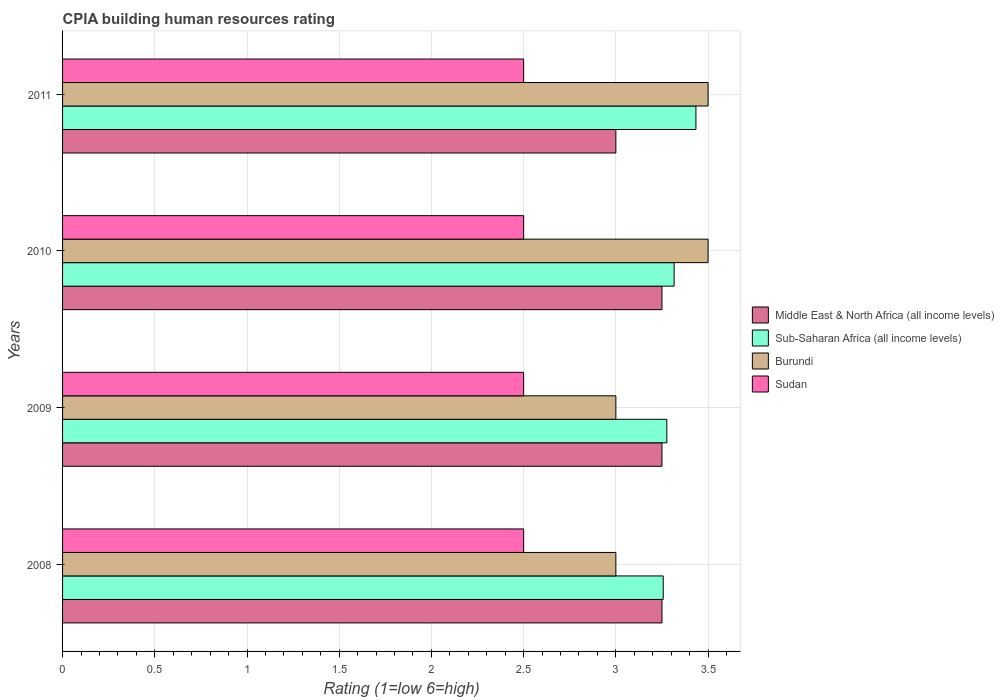Are the number of bars per tick equal to the number of legend labels?
Your response must be concise. Yes. In how many cases, is the number of bars for a given year not equal to the number of legend labels?
Your answer should be very brief. 0. Across all years, what is the minimum CPIA rating in Sudan?
Offer a terse response. 2.5. In which year was the CPIA rating in Middle East & North Africa (all income levels) minimum?
Keep it short and to the point. 2011. What is the total CPIA rating in Middle East & North Africa (all income levels) in the graph?
Keep it short and to the point. 12.75. What is the average CPIA rating in Sub-Saharan Africa (all income levels) per year?
Ensure brevity in your answer.  3.32. In how many years, is the CPIA rating in Burundi greater than 0.30000000000000004 ?
Provide a succinct answer. 4. Is the CPIA rating in Sub-Saharan Africa (all income levels) in 2009 less than that in 2011?
Offer a very short reply. Yes. What is the difference between the highest and the second highest CPIA rating in Sub-Saharan Africa (all income levels)?
Your answer should be compact. 0.12. Is the sum of the CPIA rating in Sudan in 2010 and 2011 greater than the maximum CPIA rating in Burundi across all years?
Offer a very short reply. Yes. Is it the case that in every year, the sum of the CPIA rating in Burundi and CPIA rating in Middle East & North Africa (all income levels) is greater than the sum of CPIA rating in Sudan and CPIA rating in Sub-Saharan Africa (all income levels)?
Offer a terse response. No. What does the 1st bar from the top in 2009 represents?
Offer a very short reply. Sudan. What does the 1st bar from the bottom in 2008 represents?
Your answer should be compact. Middle East & North Africa (all income levels). Is it the case that in every year, the sum of the CPIA rating in Middle East & North Africa (all income levels) and CPIA rating in Sudan is greater than the CPIA rating in Sub-Saharan Africa (all income levels)?
Provide a short and direct response. Yes. How many bars are there?
Provide a short and direct response. 16. How many years are there in the graph?
Give a very brief answer. 4. What is the difference between two consecutive major ticks on the X-axis?
Make the answer very short. 0.5. How many legend labels are there?
Your answer should be compact. 4. What is the title of the graph?
Offer a terse response. CPIA building human resources rating. What is the label or title of the X-axis?
Your response must be concise. Rating (1=low 6=high). What is the label or title of the Y-axis?
Offer a terse response. Years. What is the Rating (1=low 6=high) of Sub-Saharan Africa (all income levels) in 2008?
Your response must be concise. 3.26. What is the Rating (1=low 6=high) in Burundi in 2008?
Give a very brief answer. 3. What is the Rating (1=low 6=high) in Sub-Saharan Africa (all income levels) in 2009?
Your answer should be very brief. 3.28. What is the Rating (1=low 6=high) of Burundi in 2009?
Ensure brevity in your answer.  3. What is the Rating (1=low 6=high) in Sudan in 2009?
Offer a very short reply. 2.5. What is the Rating (1=low 6=high) in Middle East & North Africa (all income levels) in 2010?
Provide a succinct answer. 3.25. What is the Rating (1=low 6=high) in Sub-Saharan Africa (all income levels) in 2010?
Offer a terse response. 3.32. What is the Rating (1=low 6=high) of Middle East & North Africa (all income levels) in 2011?
Your response must be concise. 3. What is the Rating (1=low 6=high) of Sub-Saharan Africa (all income levels) in 2011?
Offer a terse response. 3.43. What is the Rating (1=low 6=high) of Burundi in 2011?
Make the answer very short. 3.5. Across all years, what is the maximum Rating (1=low 6=high) in Middle East & North Africa (all income levels)?
Make the answer very short. 3.25. Across all years, what is the maximum Rating (1=low 6=high) in Sub-Saharan Africa (all income levels)?
Offer a terse response. 3.43. Across all years, what is the maximum Rating (1=low 6=high) of Burundi?
Keep it short and to the point. 3.5. Across all years, what is the maximum Rating (1=low 6=high) in Sudan?
Give a very brief answer. 2.5. Across all years, what is the minimum Rating (1=low 6=high) in Middle East & North Africa (all income levels)?
Your answer should be very brief. 3. Across all years, what is the minimum Rating (1=low 6=high) of Sub-Saharan Africa (all income levels)?
Your answer should be compact. 3.26. Across all years, what is the minimum Rating (1=low 6=high) of Sudan?
Offer a terse response. 2.5. What is the total Rating (1=low 6=high) in Middle East & North Africa (all income levels) in the graph?
Keep it short and to the point. 12.75. What is the total Rating (1=low 6=high) of Sub-Saharan Africa (all income levels) in the graph?
Your answer should be very brief. 13.28. What is the total Rating (1=low 6=high) in Burundi in the graph?
Make the answer very short. 13. What is the total Rating (1=low 6=high) in Sudan in the graph?
Your answer should be very brief. 10. What is the difference between the Rating (1=low 6=high) of Middle East & North Africa (all income levels) in 2008 and that in 2009?
Offer a terse response. 0. What is the difference between the Rating (1=low 6=high) of Sub-Saharan Africa (all income levels) in 2008 and that in 2009?
Provide a short and direct response. -0.02. What is the difference between the Rating (1=low 6=high) of Burundi in 2008 and that in 2009?
Make the answer very short. 0. What is the difference between the Rating (1=low 6=high) of Middle East & North Africa (all income levels) in 2008 and that in 2010?
Offer a very short reply. 0. What is the difference between the Rating (1=low 6=high) of Sub-Saharan Africa (all income levels) in 2008 and that in 2010?
Offer a terse response. -0.06. What is the difference between the Rating (1=low 6=high) in Middle East & North Africa (all income levels) in 2008 and that in 2011?
Provide a succinct answer. 0.25. What is the difference between the Rating (1=low 6=high) of Sub-Saharan Africa (all income levels) in 2008 and that in 2011?
Your answer should be very brief. -0.18. What is the difference between the Rating (1=low 6=high) in Burundi in 2008 and that in 2011?
Ensure brevity in your answer.  -0.5. What is the difference between the Rating (1=low 6=high) in Sudan in 2008 and that in 2011?
Keep it short and to the point. 0. What is the difference between the Rating (1=low 6=high) in Sub-Saharan Africa (all income levels) in 2009 and that in 2010?
Offer a terse response. -0.04. What is the difference between the Rating (1=low 6=high) of Burundi in 2009 and that in 2010?
Your answer should be compact. -0.5. What is the difference between the Rating (1=low 6=high) in Sudan in 2009 and that in 2010?
Make the answer very short. 0. What is the difference between the Rating (1=low 6=high) in Middle East & North Africa (all income levels) in 2009 and that in 2011?
Ensure brevity in your answer.  0.25. What is the difference between the Rating (1=low 6=high) of Sub-Saharan Africa (all income levels) in 2009 and that in 2011?
Provide a succinct answer. -0.16. What is the difference between the Rating (1=low 6=high) of Sub-Saharan Africa (all income levels) in 2010 and that in 2011?
Ensure brevity in your answer.  -0.12. What is the difference between the Rating (1=low 6=high) of Burundi in 2010 and that in 2011?
Keep it short and to the point. 0. What is the difference between the Rating (1=low 6=high) of Middle East & North Africa (all income levels) in 2008 and the Rating (1=low 6=high) of Sub-Saharan Africa (all income levels) in 2009?
Ensure brevity in your answer.  -0.03. What is the difference between the Rating (1=low 6=high) of Sub-Saharan Africa (all income levels) in 2008 and the Rating (1=low 6=high) of Burundi in 2009?
Make the answer very short. 0.26. What is the difference between the Rating (1=low 6=high) in Sub-Saharan Africa (all income levels) in 2008 and the Rating (1=low 6=high) in Sudan in 2009?
Your answer should be very brief. 0.76. What is the difference between the Rating (1=low 6=high) in Middle East & North Africa (all income levels) in 2008 and the Rating (1=low 6=high) in Sub-Saharan Africa (all income levels) in 2010?
Ensure brevity in your answer.  -0.07. What is the difference between the Rating (1=low 6=high) in Sub-Saharan Africa (all income levels) in 2008 and the Rating (1=low 6=high) in Burundi in 2010?
Offer a very short reply. -0.24. What is the difference between the Rating (1=low 6=high) of Sub-Saharan Africa (all income levels) in 2008 and the Rating (1=low 6=high) of Sudan in 2010?
Make the answer very short. 0.76. What is the difference between the Rating (1=low 6=high) of Burundi in 2008 and the Rating (1=low 6=high) of Sudan in 2010?
Ensure brevity in your answer.  0.5. What is the difference between the Rating (1=low 6=high) of Middle East & North Africa (all income levels) in 2008 and the Rating (1=low 6=high) of Sub-Saharan Africa (all income levels) in 2011?
Offer a very short reply. -0.18. What is the difference between the Rating (1=low 6=high) of Middle East & North Africa (all income levels) in 2008 and the Rating (1=low 6=high) of Burundi in 2011?
Keep it short and to the point. -0.25. What is the difference between the Rating (1=low 6=high) in Middle East & North Africa (all income levels) in 2008 and the Rating (1=low 6=high) in Sudan in 2011?
Offer a very short reply. 0.75. What is the difference between the Rating (1=low 6=high) of Sub-Saharan Africa (all income levels) in 2008 and the Rating (1=low 6=high) of Burundi in 2011?
Your response must be concise. -0.24. What is the difference between the Rating (1=low 6=high) in Sub-Saharan Africa (all income levels) in 2008 and the Rating (1=low 6=high) in Sudan in 2011?
Provide a succinct answer. 0.76. What is the difference between the Rating (1=low 6=high) in Middle East & North Africa (all income levels) in 2009 and the Rating (1=low 6=high) in Sub-Saharan Africa (all income levels) in 2010?
Provide a short and direct response. -0.07. What is the difference between the Rating (1=low 6=high) in Middle East & North Africa (all income levels) in 2009 and the Rating (1=low 6=high) in Burundi in 2010?
Provide a succinct answer. -0.25. What is the difference between the Rating (1=low 6=high) of Sub-Saharan Africa (all income levels) in 2009 and the Rating (1=low 6=high) of Burundi in 2010?
Keep it short and to the point. -0.22. What is the difference between the Rating (1=low 6=high) of Sub-Saharan Africa (all income levels) in 2009 and the Rating (1=low 6=high) of Sudan in 2010?
Provide a short and direct response. 0.78. What is the difference between the Rating (1=low 6=high) in Burundi in 2009 and the Rating (1=low 6=high) in Sudan in 2010?
Offer a terse response. 0.5. What is the difference between the Rating (1=low 6=high) in Middle East & North Africa (all income levels) in 2009 and the Rating (1=low 6=high) in Sub-Saharan Africa (all income levels) in 2011?
Provide a succinct answer. -0.18. What is the difference between the Rating (1=low 6=high) of Middle East & North Africa (all income levels) in 2009 and the Rating (1=low 6=high) of Burundi in 2011?
Provide a short and direct response. -0.25. What is the difference between the Rating (1=low 6=high) of Middle East & North Africa (all income levels) in 2009 and the Rating (1=low 6=high) of Sudan in 2011?
Provide a short and direct response. 0.75. What is the difference between the Rating (1=low 6=high) in Sub-Saharan Africa (all income levels) in 2009 and the Rating (1=low 6=high) in Burundi in 2011?
Provide a succinct answer. -0.22. What is the difference between the Rating (1=low 6=high) in Sub-Saharan Africa (all income levels) in 2009 and the Rating (1=low 6=high) in Sudan in 2011?
Your answer should be very brief. 0.78. What is the difference between the Rating (1=low 6=high) in Burundi in 2009 and the Rating (1=low 6=high) in Sudan in 2011?
Make the answer very short. 0.5. What is the difference between the Rating (1=low 6=high) in Middle East & North Africa (all income levels) in 2010 and the Rating (1=low 6=high) in Sub-Saharan Africa (all income levels) in 2011?
Your answer should be compact. -0.18. What is the difference between the Rating (1=low 6=high) in Sub-Saharan Africa (all income levels) in 2010 and the Rating (1=low 6=high) in Burundi in 2011?
Your answer should be very brief. -0.18. What is the difference between the Rating (1=low 6=high) of Sub-Saharan Africa (all income levels) in 2010 and the Rating (1=low 6=high) of Sudan in 2011?
Offer a very short reply. 0.82. What is the average Rating (1=low 6=high) of Middle East & North Africa (all income levels) per year?
Your answer should be very brief. 3.19. What is the average Rating (1=low 6=high) of Sub-Saharan Africa (all income levels) per year?
Give a very brief answer. 3.32. What is the average Rating (1=low 6=high) of Sudan per year?
Your answer should be compact. 2.5. In the year 2008, what is the difference between the Rating (1=low 6=high) in Middle East & North Africa (all income levels) and Rating (1=low 6=high) in Sub-Saharan Africa (all income levels)?
Your answer should be very brief. -0.01. In the year 2008, what is the difference between the Rating (1=low 6=high) of Middle East & North Africa (all income levels) and Rating (1=low 6=high) of Burundi?
Your answer should be compact. 0.25. In the year 2008, what is the difference between the Rating (1=low 6=high) of Middle East & North Africa (all income levels) and Rating (1=low 6=high) of Sudan?
Offer a very short reply. 0.75. In the year 2008, what is the difference between the Rating (1=low 6=high) of Sub-Saharan Africa (all income levels) and Rating (1=low 6=high) of Burundi?
Your answer should be very brief. 0.26. In the year 2008, what is the difference between the Rating (1=low 6=high) in Sub-Saharan Africa (all income levels) and Rating (1=low 6=high) in Sudan?
Your response must be concise. 0.76. In the year 2008, what is the difference between the Rating (1=low 6=high) of Burundi and Rating (1=low 6=high) of Sudan?
Your answer should be compact. 0.5. In the year 2009, what is the difference between the Rating (1=low 6=high) in Middle East & North Africa (all income levels) and Rating (1=low 6=high) in Sub-Saharan Africa (all income levels)?
Ensure brevity in your answer.  -0.03. In the year 2009, what is the difference between the Rating (1=low 6=high) of Middle East & North Africa (all income levels) and Rating (1=low 6=high) of Burundi?
Offer a very short reply. 0.25. In the year 2009, what is the difference between the Rating (1=low 6=high) in Middle East & North Africa (all income levels) and Rating (1=low 6=high) in Sudan?
Ensure brevity in your answer.  0.75. In the year 2009, what is the difference between the Rating (1=low 6=high) of Sub-Saharan Africa (all income levels) and Rating (1=low 6=high) of Burundi?
Your answer should be very brief. 0.28. In the year 2009, what is the difference between the Rating (1=low 6=high) of Sub-Saharan Africa (all income levels) and Rating (1=low 6=high) of Sudan?
Your response must be concise. 0.78. In the year 2009, what is the difference between the Rating (1=low 6=high) of Burundi and Rating (1=low 6=high) of Sudan?
Your answer should be very brief. 0.5. In the year 2010, what is the difference between the Rating (1=low 6=high) of Middle East & North Africa (all income levels) and Rating (1=low 6=high) of Sub-Saharan Africa (all income levels)?
Offer a very short reply. -0.07. In the year 2010, what is the difference between the Rating (1=low 6=high) in Middle East & North Africa (all income levels) and Rating (1=low 6=high) in Burundi?
Offer a very short reply. -0.25. In the year 2010, what is the difference between the Rating (1=low 6=high) in Sub-Saharan Africa (all income levels) and Rating (1=low 6=high) in Burundi?
Give a very brief answer. -0.18. In the year 2010, what is the difference between the Rating (1=low 6=high) of Sub-Saharan Africa (all income levels) and Rating (1=low 6=high) of Sudan?
Make the answer very short. 0.82. In the year 2010, what is the difference between the Rating (1=low 6=high) in Burundi and Rating (1=low 6=high) in Sudan?
Offer a very short reply. 1. In the year 2011, what is the difference between the Rating (1=low 6=high) in Middle East & North Africa (all income levels) and Rating (1=low 6=high) in Sub-Saharan Africa (all income levels)?
Your answer should be compact. -0.43. In the year 2011, what is the difference between the Rating (1=low 6=high) of Middle East & North Africa (all income levels) and Rating (1=low 6=high) of Burundi?
Keep it short and to the point. -0.5. In the year 2011, what is the difference between the Rating (1=low 6=high) in Sub-Saharan Africa (all income levels) and Rating (1=low 6=high) in Burundi?
Provide a succinct answer. -0.07. In the year 2011, what is the difference between the Rating (1=low 6=high) of Sub-Saharan Africa (all income levels) and Rating (1=low 6=high) of Sudan?
Your answer should be compact. 0.93. What is the ratio of the Rating (1=low 6=high) in Middle East & North Africa (all income levels) in 2008 to that in 2009?
Provide a short and direct response. 1. What is the ratio of the Rating (1=low 6=high) of Sub-Saharan Africa (all income levels) in 2008 to that in 2009?
Ensure brevity in your answer.  0.99. What is the ratio of the Rating (1=low 6=high) in Burundi in 2008 to that in 2009?
Ensure brevity in your answer.  1. What is the ratio of the Rating (1=low 6=high) of Sudan in 2008 to that in 2009?
Ensure brevity in your answer.  1. What is the ratio of the Rating (1=low 6=high) of Middle East & North Africa (all income levels) in 2008 to that in 2010?
Offer a terse response. 1. What is the ratio of the Rating (1=low 6=high) of Sub-Saharan Africa (all income levels) in 2008 to that in 2010?
Ensure brevity in your answer.  0.98. What is the ratio of the Rating (1=low 6=high) of Sub-Saharan Africa (all income levels) in 2008 to that in 2011?
Make the answer very short. 0.95. What is the ratio of the Rating (1=low 6=high) in Burundi in 2008 to that in 2011?
Make the answer very short. 0.86. What is the ratio of the Rating (1=low 6=high) in Sub-Saharan Africa (all income levels) in 2009 to that in 2010?
Provide a short and direct response. 0.99. What is the ratio of the Rating (1=low 6=high) of Sub-Saharan Africa (all income levels) in 2009 to that in 2011?
Your answer should be very brief. 0.95. What is the ratio of the Rating (1=low 6=high) in Sudan in 2009 to that in 2011?
Provide a short and direct response. 1. What is the ratio of the Rating (1=low 6=high) of Middle East & North Africa (all income levels) in 2010 to that in 2011?
Your response must be concise. 1.08. What is the ratio of the Rating (1=low 6=high) in Sub-Saharan Africa (all income levels) in 2010 to that in 2011?
Offer a terse response. 0.97. What is the ratio of the Rating (1=low 6=high) of Burundi in 2010 to that in 2011?
Provide a short and direct response. 1. What is the ratio of the Rating (1=low 6=high) in Sudan in 2010 to that in 2011?
Offer a terse response. 1. What is the difference between the highest and the second highest Rating (1=low 6=high) of Sub-Saharan Africa (all income levels)?
Ensure brevity in your answer.  0.12. What is the difference between the highest and the second highest Rating (1=low 6=high) in Sudan?
Ensure brevity in your answer.  0. What is the difference between the highest and the lowest Rating (1=low 6=high) of Middle East & North Africa (all income levels)?
Make the answer very short. 0.25. What is the difference between the highest and the lowest Rating (1=low 6=high) of Sub-Saharan Africa (all income levels)?
Ensure brevity in your answer.  0.18. What is the difference between the highest and the lowest Rating (1=low 6=high) in Burundi?
Offer a very short reply. 0.5. What is the difference between the highest and the lowest Rating (1=low 6=high) of Sudan?
Your answer should be very brief. 0. 